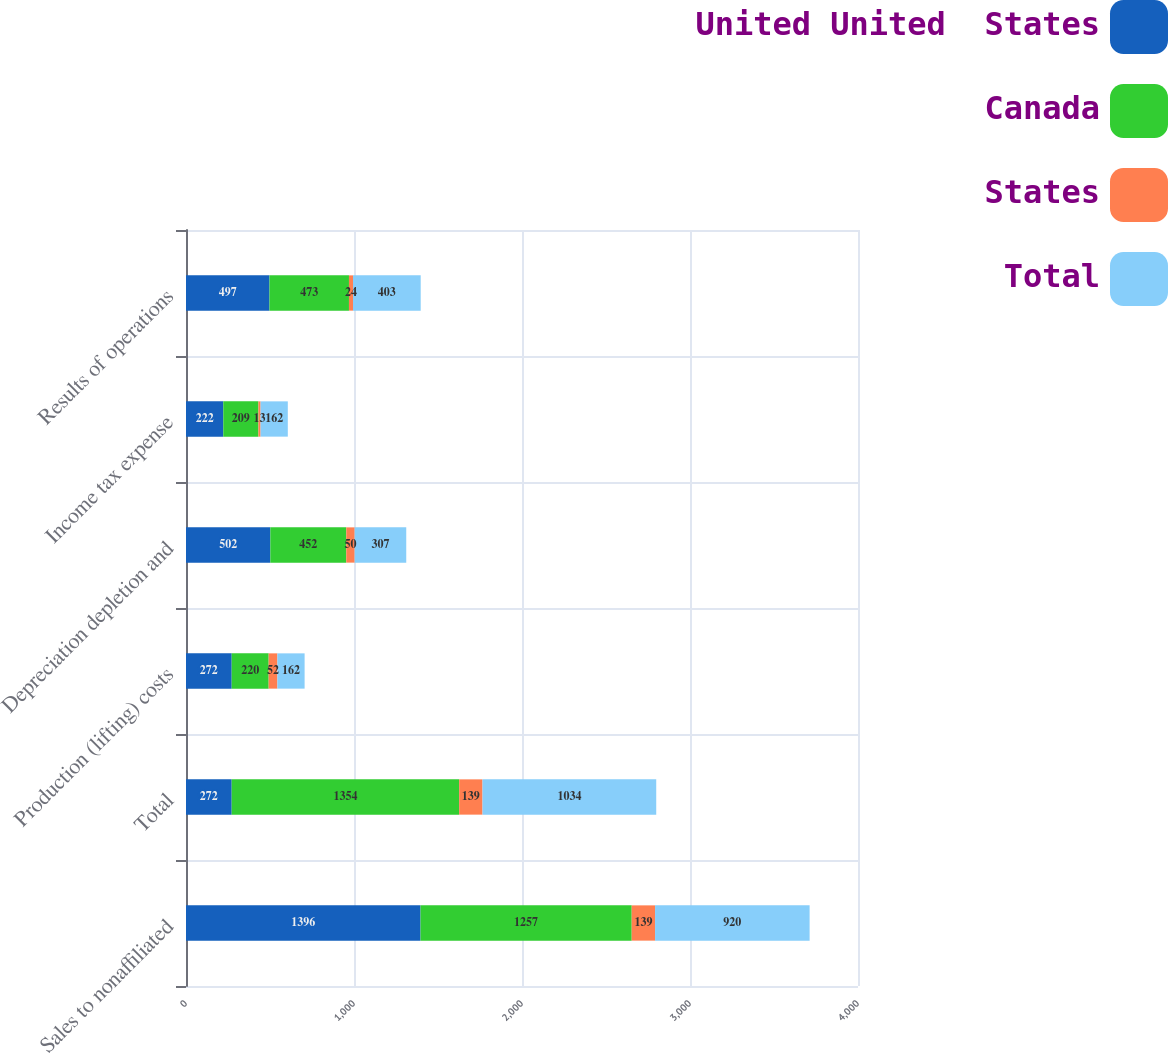Convert chart to OTSL. <chart><loc_0><loc_0><loc_500><loc_500><stacked_bar_chart><ecel><fcel>Sales to nonaffiliated<fcel>Total<fcel>Production (lifting) costs<fcel>Depreciation depletion and<fcel>Income tax expense<fcel>Results of operations<nl><fcel>United United  States<fcel>1396<fcel>272<fcel>272<fcel>502<fcel>222<fcel>497<nl><fcel>Canada<fcel>1257<fcel>1354<fcel>220<fcel>452<fcel>209<fcel>473<nl><fcel>States<fcel>139<fcel>139<fcel>52<fcel>50<fcel>13<fcel>24<nl><fcel>Total<fcel>920<fcel>1034<fcel>162<fcel>307<fcel>162<fcel>403<nl></chart> 